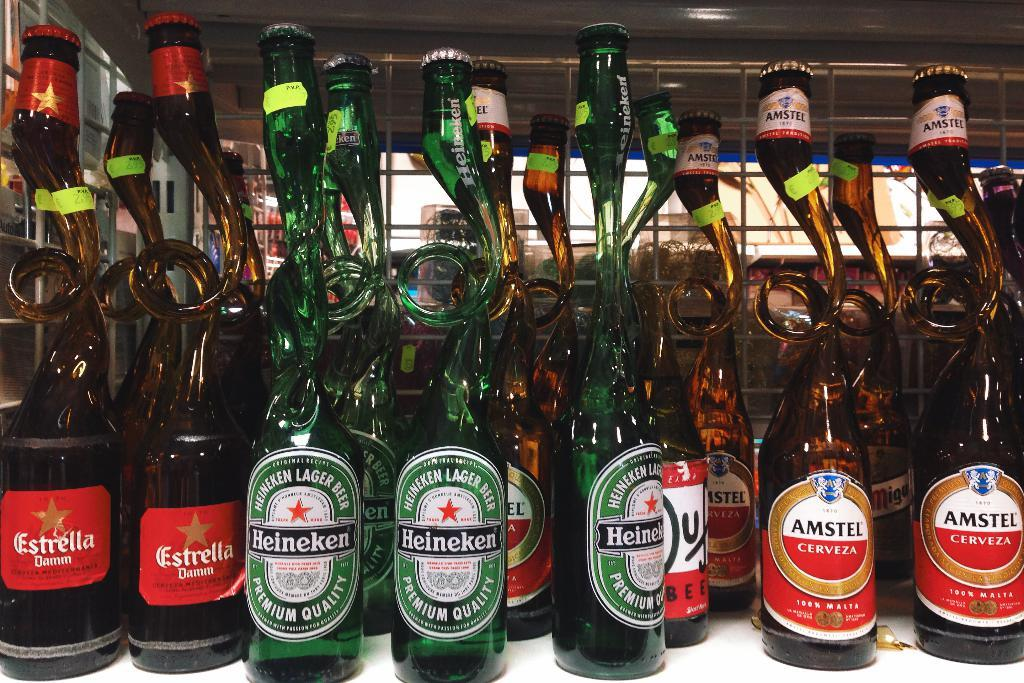<image>
Describe the image concisely. Several bottles of Estrella, Heiniken and Amstel beer 